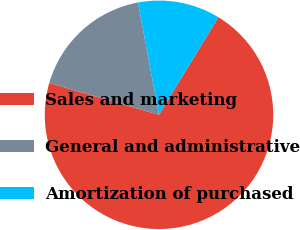<chart> <loc_0><loc_0><loc_500><loc_500><pie_chart><fcel>Sales and marketing<fcel>General and administrative<fcel>Amortization of purchased<nl><fcel>70.79%<fcel>17.56%<fcel>11.65%<nl></chart> 